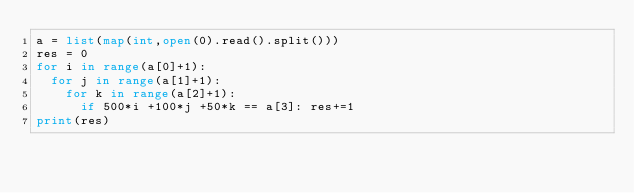Convert code to text. <code><loc_0><loc_0><loc_500><loc_500><_Python_>a = list(map(int,open(0).read().split()))
res = 0
for i in range(a[0]+1):
  for j in range(a[1]+1):
    for k in range(a[2]+1):
      if 500*i +100*j +50*k == a[3]: res+=1
print(res)</code> 